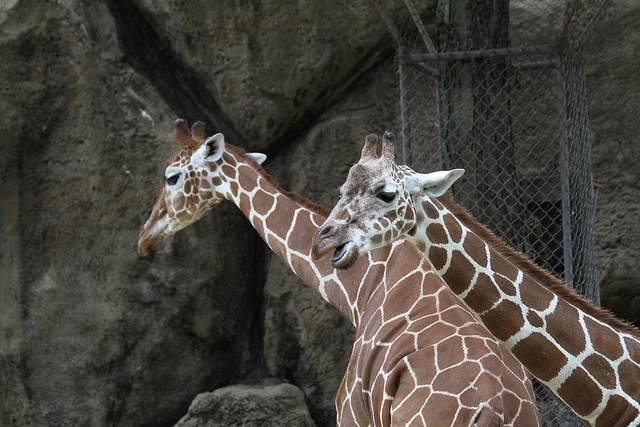Describe the objects in this image and their specific colors. I can see giraffe in gray, lightgray, and darkgray tones and giraffe in gray, black, maroon, and darkgray tones in this image. 